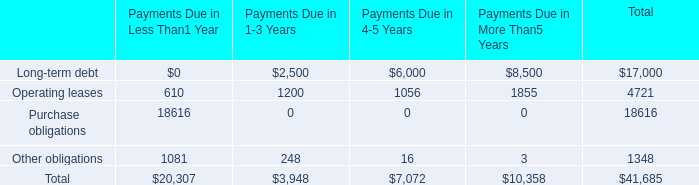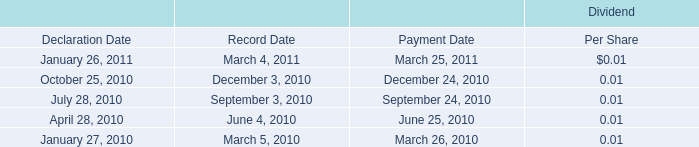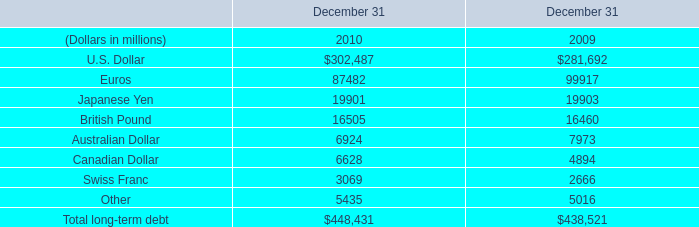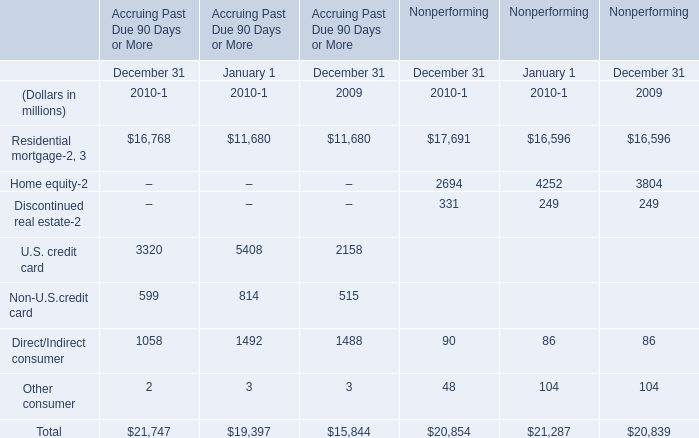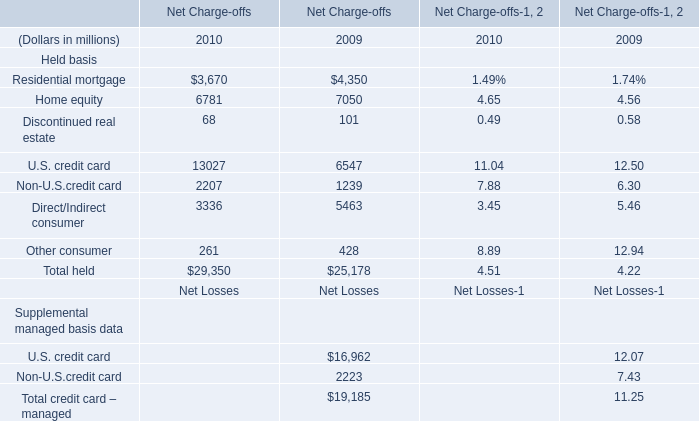Which year is Other consumer in Nonperforming the least? 
Answer: 2010. 